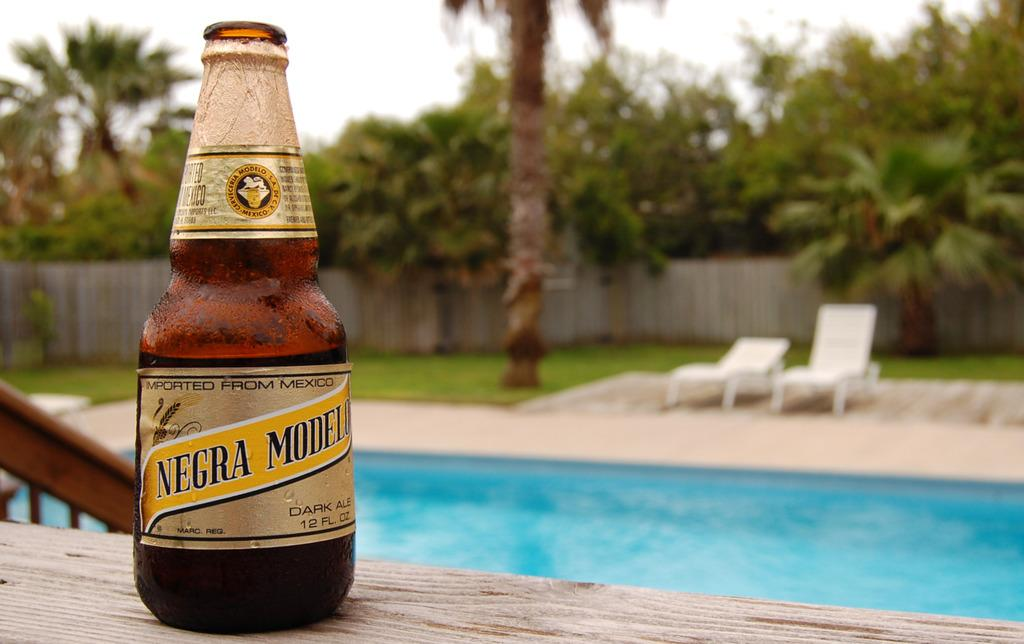<image>
Describe the image concisely. A bottle of beer that has been imported from Mexico. 